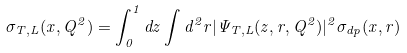<formula> <loc_0><loc_0><loc_500><loc_500>\sigma _ { T , L } ( x , Q ^ { 2 } ) = \int _ { 0 } ^ { 1 } d z \int d ^ { 2 } r | \Psi _ { T , L } ( z , r , Q ^ { 2 } ) | ^ { 2 } \sigma _ { d p } ( x , r )</formula> 